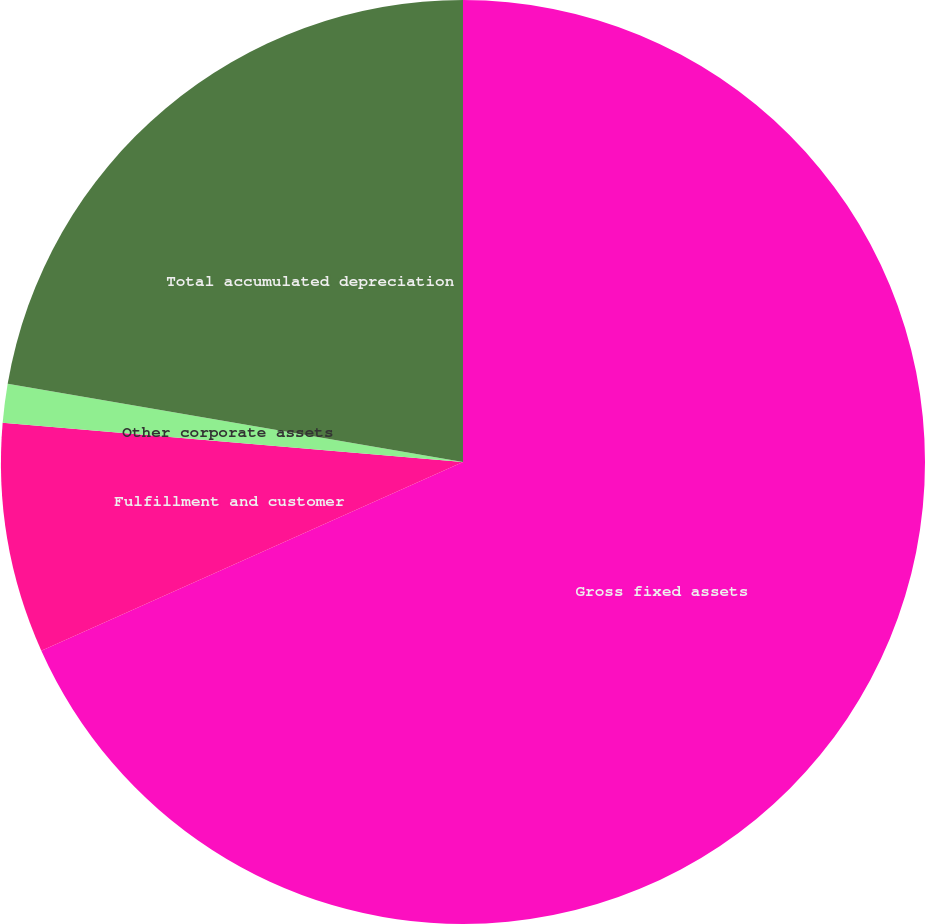Convert chart. <chart><loc_0><loc_0><loc_500><loc_500><pie_chart><fcel>Gross fixed assets<fcel>Fulfillment and customer<fcel>Other corporate assets<fcel>Total accumulated depreciation<nl><fcel>68.3%<fcel>8.05%<fcel>1.36%<fcel>22.29%<nl></chart> 